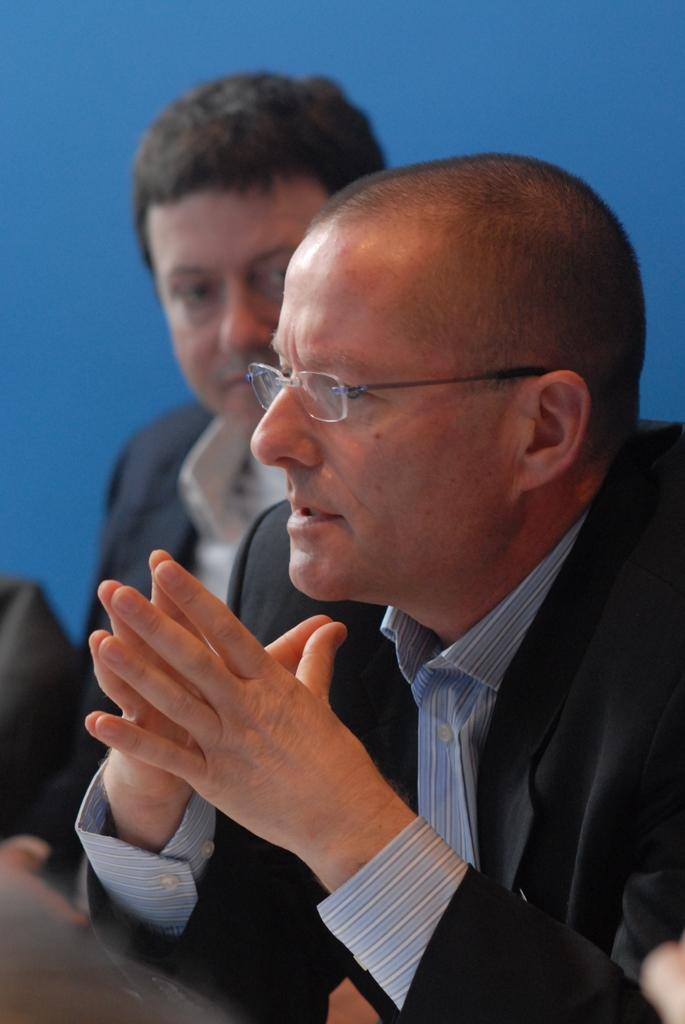How many people are present in the image? There are two persons in the image. What can be seen in the background of the image? The background of the image is blue. What time of day is depicted in the image? The provided facts do not mention the time of day, so it cannot be determined from the image. Is there a veil visible on either of the persons in the image? There is no mention of a veil in the image, so it cannot be determined if one is present. 